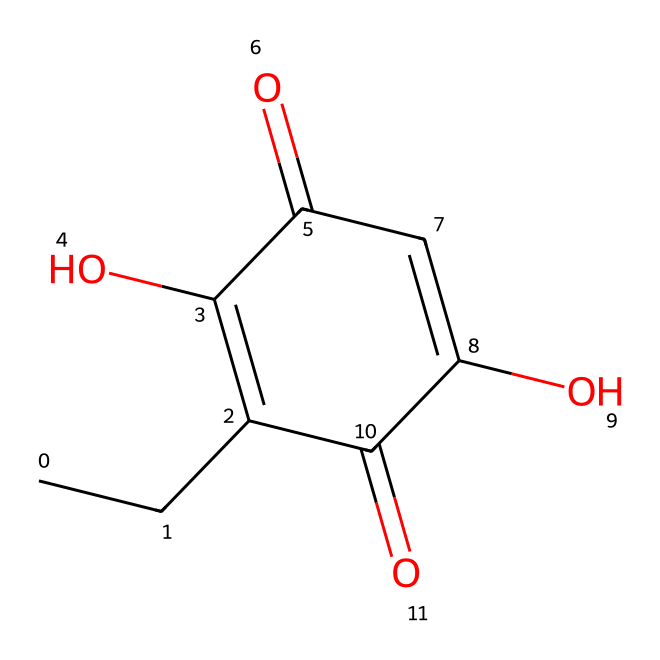What is the molecular formula of ethyl maltol? By analyzing the structure represented by the SMILES notation, we can identify each type of atom present. The structure shows carbon, hydrogen, and oxygen atoms. Counting them: there are 6 carbon atoms, 6 hydrogen atoms, and 4 oxygen atoms, leading to the formula C6H6O4.
Answer: C6H6O4 How many rings are in the structure of ethyl maltol? The structural representation indicates that there is one closed loop of atoms; thus, it contains a single ring. This ring consists of carbon and oxygen atoms.
Answer: 1 What type of functional groups are present in ethyl maltol? Examining the structure, ethyl maltol contains hydroxyl (-OH) groups and carbonyl (C=O) groups, which are indicative of a ketone and phenolic compound. This combination of functional groups is characteristic of sweet fragrance compounds.
Answer: hydroxyl and carbonyl What is the main characteristic of ethyl maltol that contributes to its sweet aroma? The structural elements of ethyl maltol, particularly the carbonyl and hydroxyl functional groups, create a specific resonance stabilization in the molecule that enhances its sweet fragrance. This makes ethyl maltol a favored compound in flavorings.
Answer: sweet aroma Does ethyl maltol exhibit any isomerism? While analyzing the structure suggests no visible isomerization, ethyl maltol can exist in forms that differ in the arrangement of atoms due to its functional groups. However, in this case, the configuration given does not indicate specific stereoisomers.
Answer: no How does ethyl maltol compare to regular maltol in sweetness? Ethyl maltol is structurally similar to maltol but has an ethyl substituent; this modification enhances its sweetness profile compared to regular maltol, making it significantly sweeter, often recognized in flavoring applications for vape juices.
Answer: sweeter 